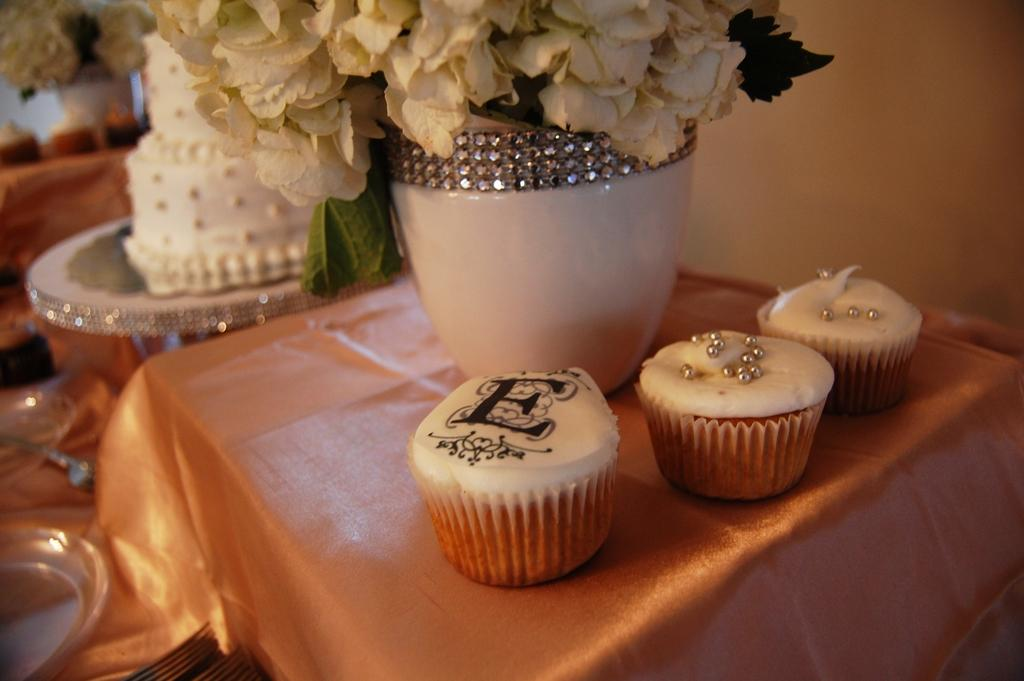What type of furniture is present in the image? There are tables in the image. What kind of food items can be seen on the tables? There are cupcakes on the tables. Are there any decorative elements on the tables? Yes, there are flowers on the tables. What else can be found on the tables? There is a plate on the tables. What is the main focus of the image? There is a cake in the center of the image. Can you hear the horn in the image? There is no horn present in the image, so it cannot be heard. Is anyone expressing anger in the image? There is no indication of anger in the image; it features tables with cupcakes, flowers, a plate, and a cake. 